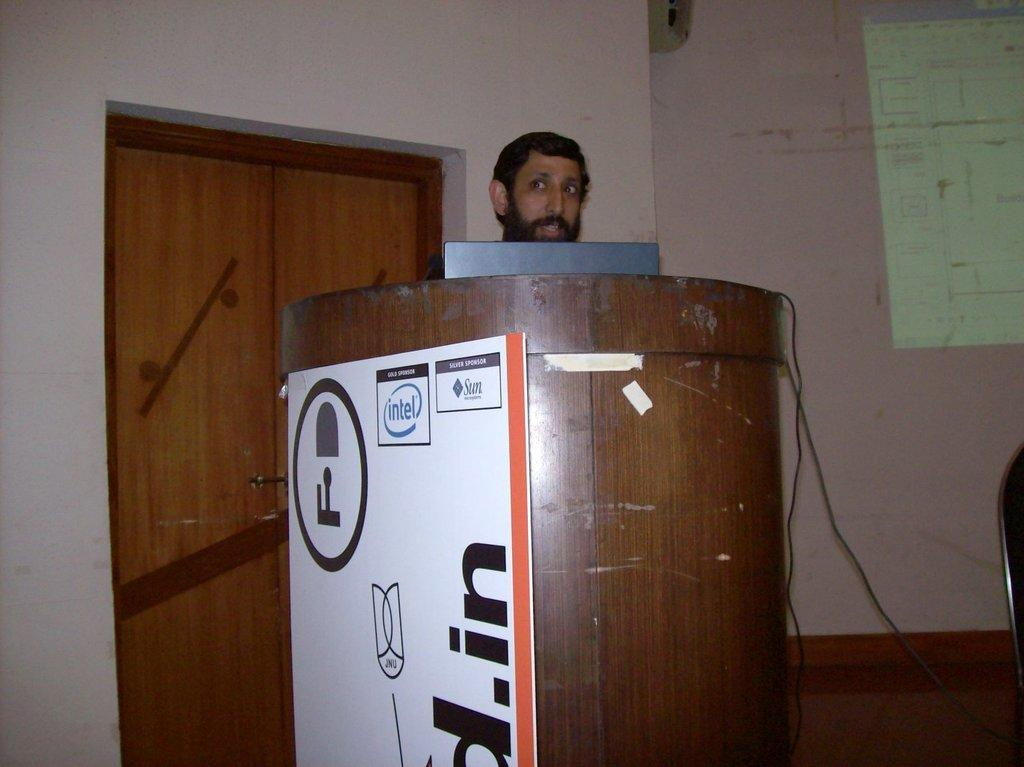<image>
Write a terse but informative summary of the picture. A man stands behind a large podium with an Intel logo on it. 